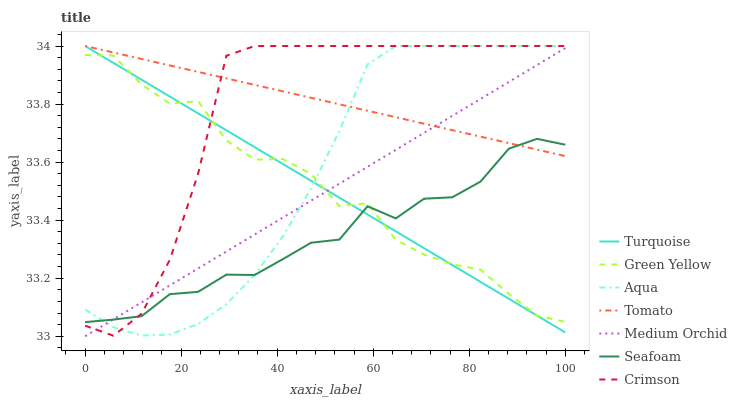Does Seafoam have the minimum area under the curve?
Answer yes or no. Yes. Does Tomato have the maximum area under the curve?
Answer yes or no. Yes. Does Turquoise have the minimum area under the curve?
Answer yes or no. No. Does Turquoise have the maximum area under the curve?
Answer yes or no. No. Is Medium Orchid the smoothest?
Answer yes or no. Yes. Is Green Yellow the roughest?
Answer yes or no. Yes. Is Turquoise the smoothest?
Answer yes or no. No. Is Turquoise the roughest?
Answer yes or no. No. Does Medium Orchid have the lowest value?
Answer yes or no. Yes. Does Turquoise have the lowest value?
Answer yes or no. No. Does Crimson have the highest value?
Answer yes or no. Yes. Does Medium Orchid have the highest value?
Answer yes or no. No. Is Green Yellow less than Tomato?
Answer yes or no. Yes. Is Tomato greater than Green Yellow?
Answer yes or no. Yes. Does Crimson intersect Aqua?
Answer yes or no. Yes. Is Crimson less than Aqua?
Answer yes or no. No. Is Crimson greater than Aqua?
Answer yes or no. No. Does Green Yellow intersect Tomato?
Answer yes or no. No. 